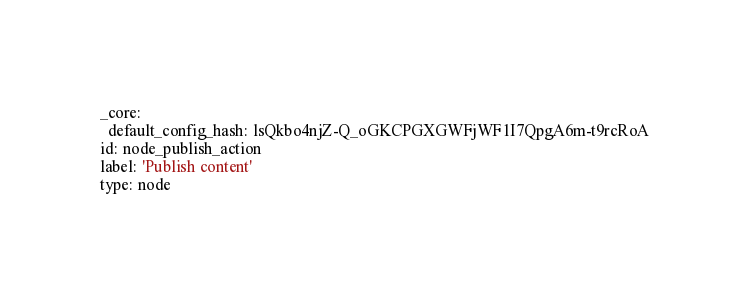Convert code to text. <code><loc_0><loc_0><loc_500><loc_500><_YAML_>_core:
  default_config_hash: lsQkbo4njZ-Q_oGKCPGXGWFjWF1I7QpgA6m-t9rcRoA
id: node_publish_action
label: 'Publish content'
type: node</code> 